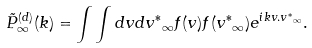<formula> <loc_0><loc_0><loc_500><loc_500>\tilde { P } ^ { ( d ) } _ { \infty } ( k ) = \int \int d { v } d { v ^ { * } } _ { \infty } f ( { v } ) f ( { v ^ { * } } _ { \infty } ) e ^ { i k { v } . { v ^ { * } } _ { \infty } } .</formula> 